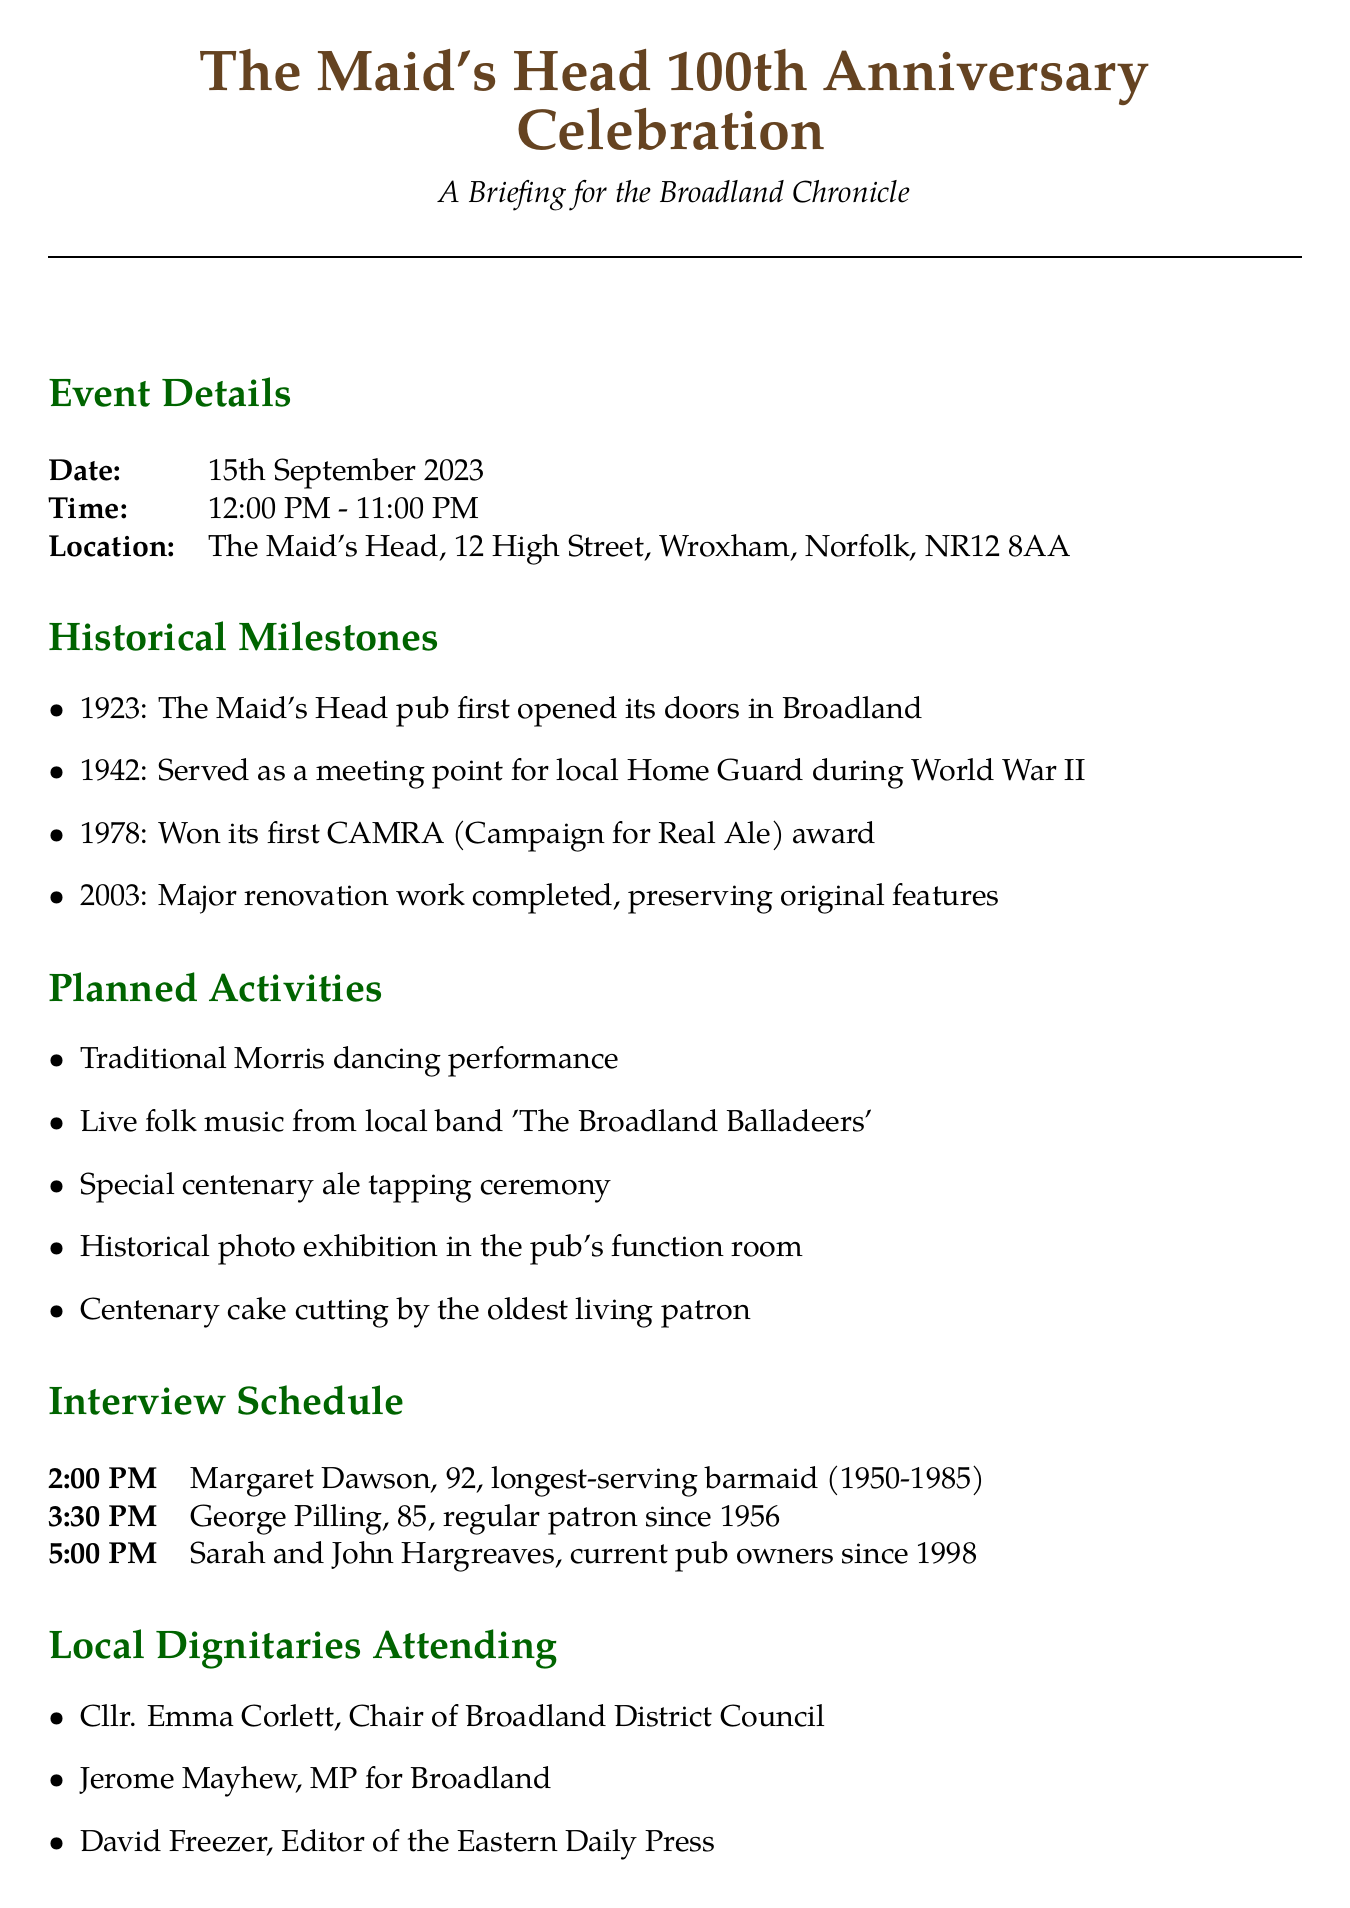What year did The Maid's Head first open? The document states that The Maid's Head pub first opened in Broadland in 1923.
Answer: 1923 What is the time of the centenary celebration? The event details section specifies that the celebration runs from 12:00 PM to 11:00 PM.
Answer: 12:00 PM - 11:00 PM Who was the longest-serving barmaid? According to the interview schedule, Margaret Dawson served as the longest-serving barmaid from 1950 to 1985.
Answer: Margaret Dawson What special event will take place at 5:00 PM? The interview schedule indicates that Sarah and John Hargreaves, the current pub owners, will be interviewed at that time.
Answer: Interview with Sarah and John Hargreaves Name one activity planned for the celebration. The planned activities include a traditional Morris dancing performance.
Answer: Traditional Morris dancing performance Which dignitary represents the local council? The document lists Cllr. Emma Corlett as the Chair of Broadland District Council who will be attending.
Answer: Cllr. Emma Corlett What year did The Maid's Head win its first CAMRA award? The historical milestones section notes that the pub won its first CAMRA award in 1978.
Answer: 1978 What is one impact of The Maid's Head on the community? The community impact section mentions longstanding support for local charities, including Wroxham and Hoveton Lions Club.
Answer: Support for local charities 